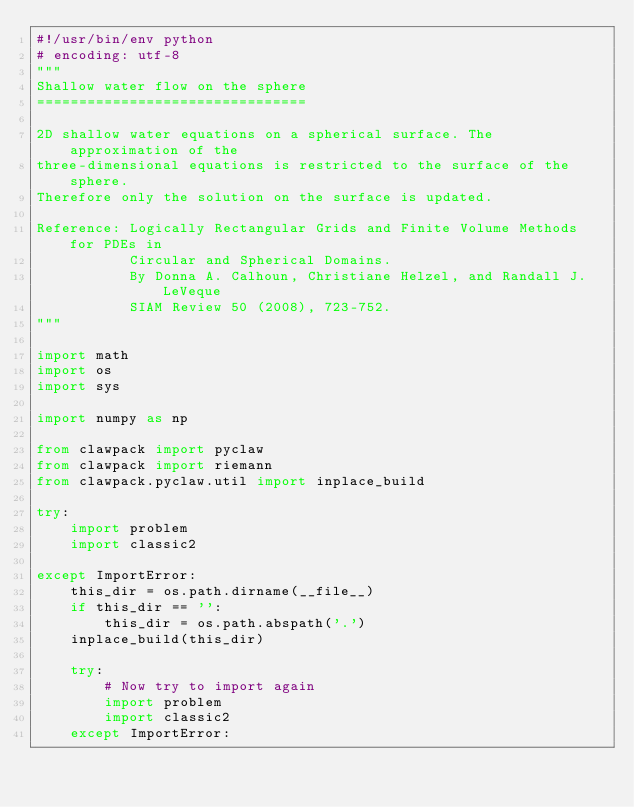<code> <loc_0><loc_0><loc_500><loc_500><_Python_>#!/usr/bin/env python
# encoding: utf-8
"""
Shallow water flow on the sphere
================================

2D shallow water equations on a spherical surface. The approximation of the 
three-dimensional equations is restricted to the surface of the sphere. 
Therefore only the solution on the surface is updated. 

Reference: Logically Rectangular Grids and Finite Volume Methods for PDEs in 
           Circular and Spherical Domains. 
           By Donna A. Calhoun, Christiane Helzel, and Randall J. LeVeque
           SIAM Review 50 (2008), 723-752. 
"""

import math
import os
import sys

import numpy as np

from clawpack import pyclaw
from clawpack import riemann
from clawpack.pyclaw.util import inplace_build

try:
    import problem
    import classic2

except ImportError:
    this_dir = os.path.dirname(__file__)
    if this_dir == '':
        this_dir = os.path.abspath('.')
    inplace_build(this_dir)

    try:
        # Now try to import again
        import problem
        import classic2
    except ImportError:</code> 